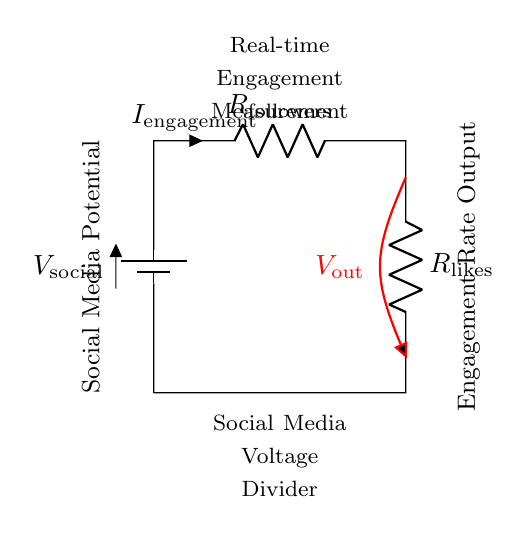What is the source voltage in this circuit? The source voltage is denoted by V social, which represents the supply voltage in the circuit.
Answer: V social What are the resistances used in this voltage divider? The resistances in the circuit are R followers and R likes, which are positioned in series in the voltage divider configuration.
Answer: R followers, R likes What is the output voltage referred to in this circuit? The output voltage is labeled as V out, indicating the voltage measured across the second resistor, R likes, in the voltage divider.
Answer: V out How does the engagement current relate to the resistances? The engagement current, I engagement, is influenced by the voltage drop across the resistors R followers and R likes, following Ohm's law, which states I equals V over R for this series configuration.
Answer: It relates by Ohm's law What is the relationship between the resistors and the output voltage? The output voltage V out is directly related to the ratios of the resistances R likes and R followers, dictated by the voltage divider rule: V out equals V social multiplied by the fraction of R likes over the total resistance.
Answer: Voltage divider rule Why is this configuration called a voltage divider? This configuration is termed a voltage divider because it divides the input supply voltage into smaller output voltages, based on the values of the resistances in series.
Answer: Because it divides voltage How can this circuit be applied to measure social media engagement rates? This circuit can measure social media engagement rates by interpreting the values of the resistances R followers and R likes in terms of follower counts and likes, thus translating voltage readings into engagement metrics.
Answer: By translating voltages to engagement metrics 